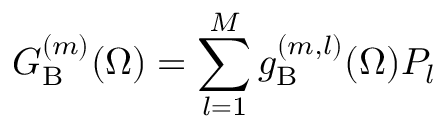Convert formula to latex. <formula><loc_0><loc_0><loc_500><loc_500>G _ { B } ^ { ( m ) } ( \Omega ) = \sum _ { l = 1 } ^ { M } { g _ { B } ^ { ( m , l ) } ( \Omega ) { P } _ { l } }</formula> 